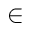Convert formula to latex. <formula><loc_0><loc_0><loc_500><loc_500>\in</formula> 